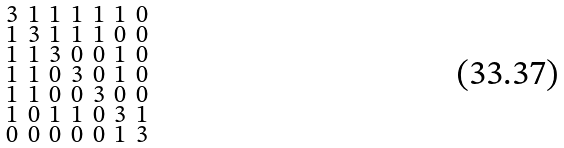<formula> <loc_0><loc_0><loc_500><loc_500>\begin{smallmatrix} 3 & 1 & 1 & 1 & 1 & 1 & 0 \\ 1 & 3 & 1 & 1 & 1 & 0 & 0 \\ 1 & 1 & 3 & 0 & 0 & 1 & 0 \\ 1 & 1 & 0 & 3 & 0 & 1 & 0 \\ 1 & 1 & 0 & 0 & 3 & 0 & 0 \\ 1 & 0 & 1 & 1 & 0 & 3 & 1 \\ 0 & 0 & 0 & 0 & 0 & 1 & 3 \end{smallmatrix}</formula> 